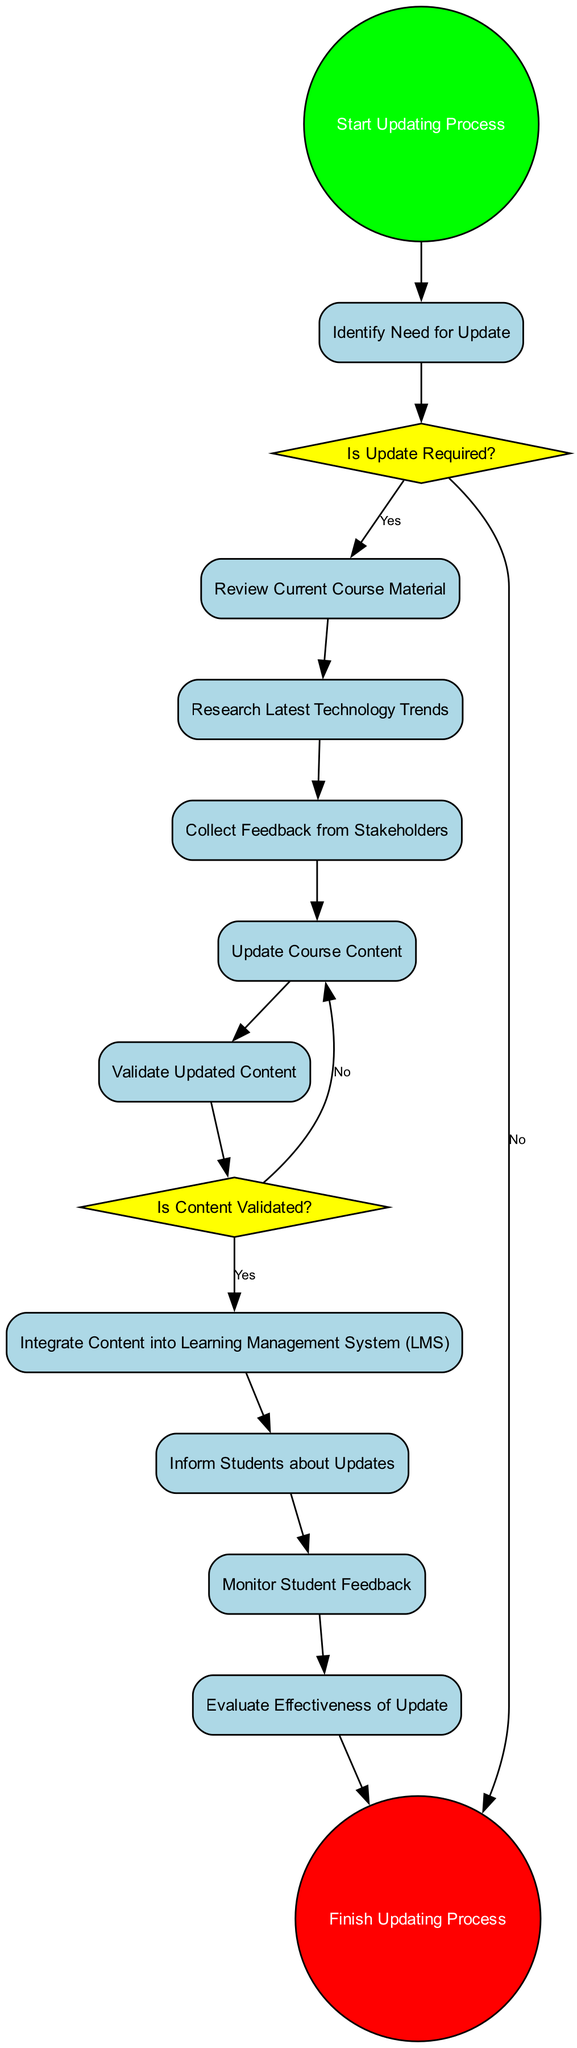What is the first activity in the diagram? The diagram starts from the "Start Updating Process" node, leading directly to the first activity, which is "Identify Need for Update."
Answer: Identify Need for Update How many decision points are present in the diagram? The diagram contains two decision points: "Is Update Required?" and "Is Content Validated?" Therefore, the total is two.
Answer: 2 What happens if the update is not required? If the update is not required, the flow goes from "Is Update Required?" directly to the end node, which signifies the completion of the process without any updates.
Answer: End Which activity follows "Validate Updated Content"? After "Validate Updated Content," the next activity is "Integrate Content into Learning Management System (LMS)," indicating the continuation of the update process after validation.
Answer: Integrate Content into Learning Management System (LMS) What is the last activity before the end of the process? The last activity in the flow before reaching the end node is "Evaluate Effectiveness of Update," where the impact of the updates is analyzed.
Answer: Evaluate Effectiveness of Update What is the relationship between "Review Current Course Material" and "Research Latest Technology Trends"? After reviewing current course material, the next step in the process is to "Research Latest Technology Trends," showing a sequential relationship where research follows the review.
Answer: Sequential relationship What does the decision point "Is Content Validated?" check for? This decision point checks whether the updated content has received all necessary approvals and validations, ensuring quality before further actions are taken.
Answer: Content validity What is the total number of activities in the diagram? The diagram outlines a total of ten activities ranging from identifying needs to evaluating effectiveness, highlighting the comprehensive process involved in updating course material.
Answer: 10 